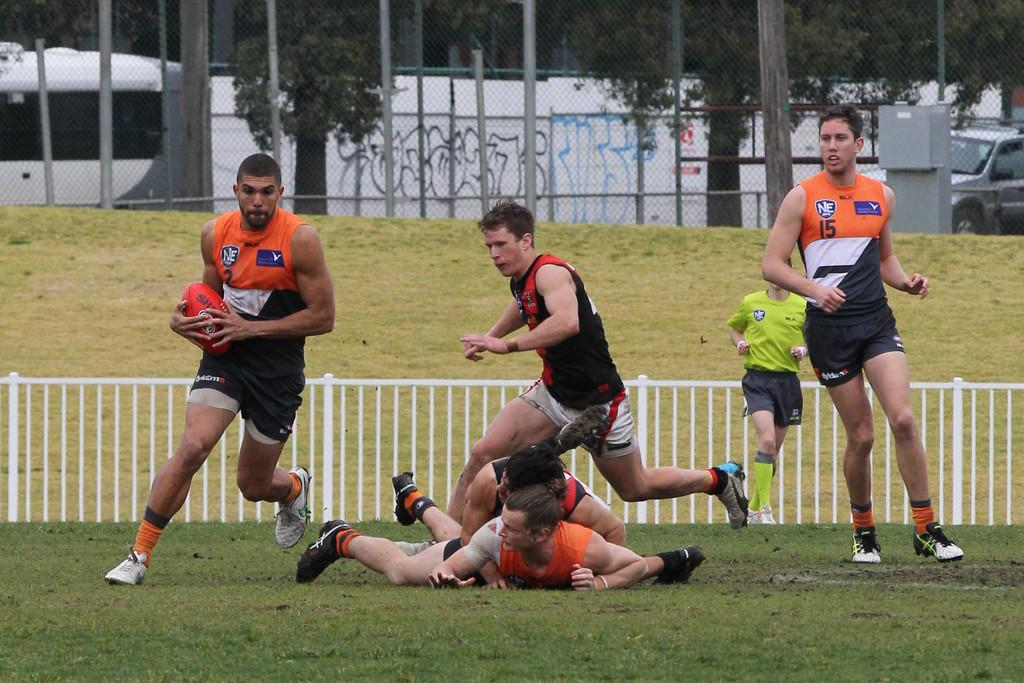Provide a one-sentence caption for the provided image. The man in the number 2 jersey runs across the field with a rugby ball. 